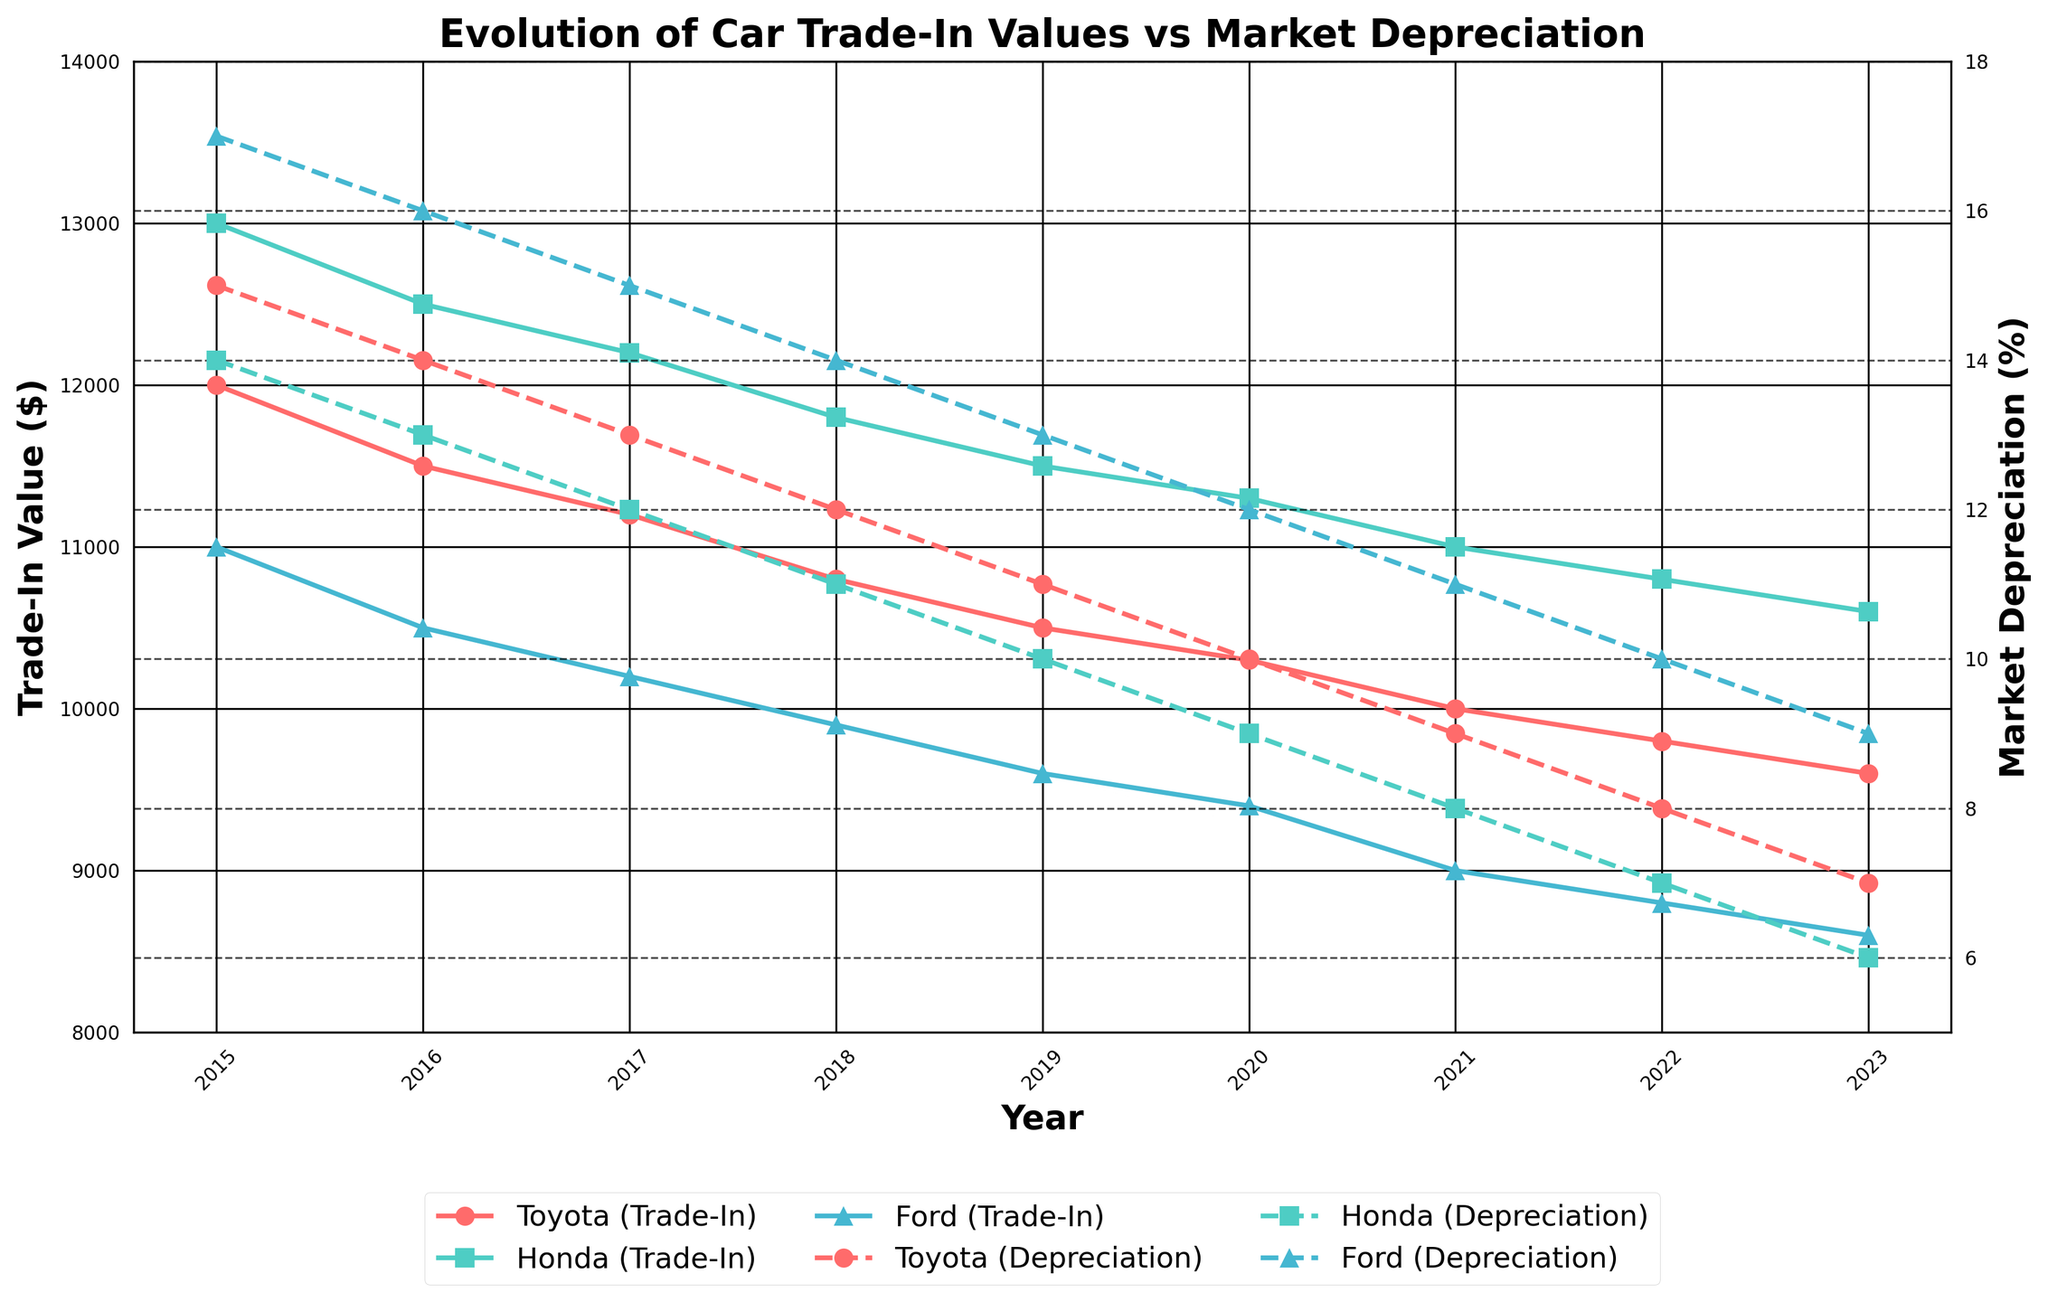What's the difference in trade-in value for the Toyota Corolla between 2015 and 2023? First, identify the trade-in values for the Toyota Corolla in 2015 and 2023 from the plot. In 2015, the trade-in value is $12,000, and in 2023, it is $9,600. Subtract the 2023 value from the 2015 value to get the difference: $12,000 - $9,600 = $2,400
Answer: $2,400 Which car make has the lowest trade-in value in 2023? Compare the trade-in values for Toyota Corolla, Honda Civic, and Ford Focus in 2023. According to the plot, Ford Focus has the lowest trade-in value at $8,600.
Answer: Ford Focus How did the market depreciation rate for the Honda Civic change from 2015 to 2018? Check the market depreciation rates for the Honda Civic in 2015 and 2018 from the graph. In 2015, the depreciation rate is 14%, and in 2018, it is 11%. The change is a decrease of 14% - 11% = 3%.
Answer: Decreased by 3% What's the average trade-in value for the Ford Focus over the years shown? Identify the trade-in values for the Ford Focus from 2015 to 2023: $11,000, $10,500, $10,200, $9,900, $9,600, $9,400, $9,000, $8,800, $8,600. Sum these values: $11,000 + $10,500 + $10,200 + $9,900 + $9,600 + $9,400 + $9,000 + $8,800 + $8,600 = $86,000. The average is $86,000 / 9 = $9,555.56
Answer: $9,555.56 Compare the trade-in value trend of Honda Civic and Toyota Corolla between 2016 and 2020. Observe the trade-in values for both Honda Civic and Toyota Corolla between 2016 and 2020. The trade-in values for the Honda Civic decrease from $12,500 to $11,300, while for the Toyota Corolla, they also decrease from $11,500 to $10,300. Both show a decreasing trend.
Answer: Both decrease During which year does the Ford Focus have the highest market depreciation rate, and what is it? Check the market depreciation rates for Ford Focus from 2015 to 2023 according to the plot. The highest rate is 17% in 2015.
Answer: 2015 at 17% In 2021, which car make had the highest trade-in value and which had the lowest market depreciation rate? According to the 2021 data on the plot, the Honda Civic had the highest trade-in value at $11,000, and the Honda Civic also had the lowest market depreciation rate at 8%.
Answer: Honda Civic for both How does the market depreciation rate for the Ford Focus in 2018 compare to the Toyota Corolla in the same year? Look at the market depreciation rates for both cars in 2018. Ford Focus has 14%, and Toyota Corolla has 12%. Therefore, Ford Focus has a higher rate.
Answer: Ford Focus has a higher rate 